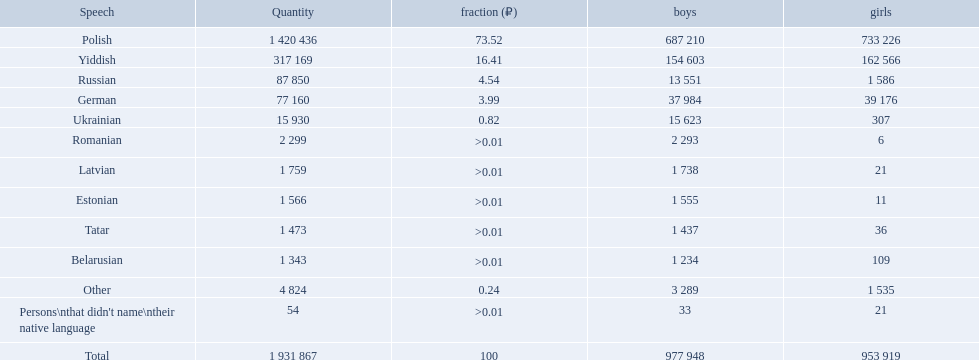What named native languages spoken in the warsaw governorate have more males then females? Russian, Ukrainian, Romanian, Latvian, Estonian, Tatar, Belarusian. Which of those have less then 500 males listed? Romanian, Latvian, Estonian, Tatar, Belarusian. Of the remaining languages which of them have less then 20 females? Romanian, Estonian. Which of these has the highest total number listed? Romanian. What are all of the languages used in the warsaw governorate? Polish, Yiddish, Russian, German, Ukrainian, Romanian, Latvian, Estonian, Tatar, Belarusian, Other, Persons\nthat didn't name\ntheir native language. Which language was comprised of the least number of female speakers? Romanian. What are all the languages? Polish, Yiddish, Russian, German, Ukrainian, Romanian, Latvian, Estonian, Tatar, Belarusian, Other, Persons\nthat didn't name\ntheir native language. Of those languages, which five had fewer than 50 females speaking it? 6, 21, 11, 36, 21. Of those five languages, which is the lowest? Romanian. What languages are spoken in the warsaw governorate? Polish, Yiddish, Russian, German, Ukrainian, Romanian, Latvian, Estonian, Tatar, Belarusian. Which are the top five languages? Polish, Yiddish, Russian, German, Ukrainian. Of those which is the 2nd most frequently spoken? Yiddish. How many languages are there? Polish, Yiddish, Russian, German, Ukrainian, Romanian, Latvian, Estonian, Tatar, Belarusian. Which language do more people speak? Polish. What were all the languages? Polish, Yiddish, Russian, German, Ukrainian, Romanian, Latvian, Estonian, Tatar, Belarusian, Other, Persons\nthat didn't name\ntheir native language. For these, how many people spoke them? 1 420 436, 317 169, 87 850, 77 160, 15 930, 2 299, 1 759, 1 566, 1 473, 1 343, 4 824, 54. Of these, which is the largest number of speakers? 1 420 436. Which language corresponds to this number? Polish. Give me the full table as a dictionary. {'header': ['Speech', 'Quantity', 'fraction (₽)', 'boys', 'girls'], 'rows': [['Polish', '1 420 436', '73.52', '687 210', '733 226'], ['Yiddish', '317 169', '16.41', '154 603', '162 566'], ['Russian', '87 850', '4.54', '13 551', '1 586'], ['German', '77 160', '3.99', '37 984', '39 176'], ['Ukrainian', '15 930', '0.82', '15 623', '307'], ['Romanian', '2 299', '>0.01', '2 293', '6'], ['Latvian', '1 759', '>0.01', '1 738', '21'], ['Estonian', '1 566', '>0.01', '1 555', '11'], ['Tatar', '1 473', '>0.01', '1 437', '36'], ['Belarusian', '1 343', '>0.01', '1 234', '109'], ['Other', '4 824', '0.24', '3 289', '1 535'], ["Persons\\nthat didn't name\\ntheir native language", '54', '>0.01', '33', '21'], ['Total', '1 931 867', '100', '977 948', '953 919']]} What are all the languages? Polish, Yiddish, Russian, German, Ukrainian, Romanian, Latvian, Estonian, Tatar, Belarusian, Other. Which only have percentages >0.01? Romanian, Latvian, Estonian, Tatar, Belarusian. Of these, which has the greatest number of speakers? Romanian. Which languages are spoken by more than 50,000 people? Polish, Yiddish, Russian, German. Of these languages, which ones are spoken by less than 15% of the population? Russian, German. Of the remaining two, which one is spoken by 37,984 males? German. 